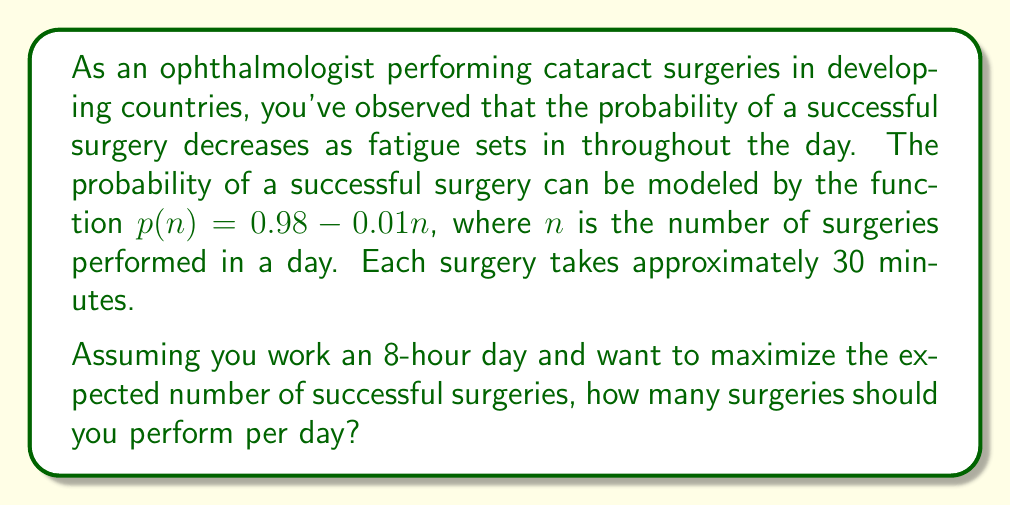Could you help me with this problem? To solve this problem, we need to follow these steps:

1) First, let's define our objective function. We want to maximize the expected number of successful surgeries, which is given by:

   $E(n) = n \cdot p(n)$

   where $n$ is the number of surgeries and $p(n)$ is the probability of success for each surgery.

2) Substituting the given probability function:

   $E(n) = n \cdot (0.98 - 0.01n) = 0.98n - 0.01n^2$

3) To find the maximum of this function, we need to differentiate it with respect to $n$ and set it to zero:

   $$\frac{dE}{dn} = 0.98 - 0.02n = 0$$

4) Solving this equation:

   $0.98 - 0.02n = 0$
   $0.98 = 0.02n$
   $n = 49$

5) To confirm this is a maximum (not a minimum), we can check the second derivative:

   $$\frac{d^2E}{dn^2} = -0.02$$

   This is negative, confirming we have found a maximum.

6) However, we need to consider the constraint of an 8-hour workday. With each surgery taking 30 minutes, the maximum number of surgeries possible in 8 hours is:

   $8 \text{ hours} \cdot \frac{60 \text{ minutes/hour}}{30 \text{ minutes/surgery}} = 16 \text{ surgeries}$

7) Since our unconstrained maximum (49) exceeds this limit, we should perform the maximum number of surgeries possible within the time constraint, which is 16.
Answer: The optimal number of surgeries to perform per day is 16. 